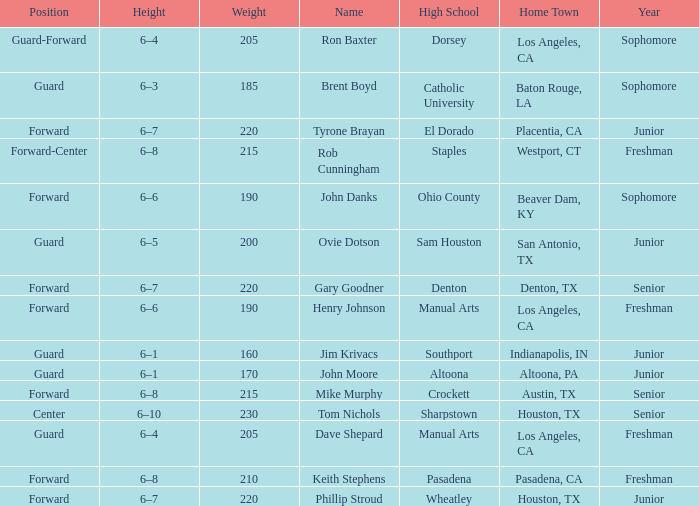What is the Name with a Year with freshman, and a Home Town with los angeles, ca, and a Height of 6–4? Dave Shepard. 